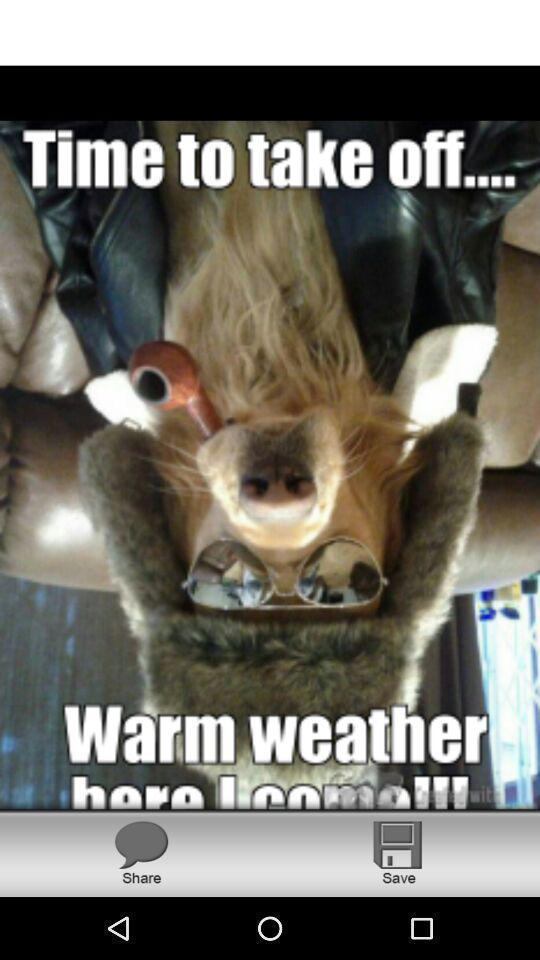Tell me what you see in this picture. Screen showing a picture in a device. 